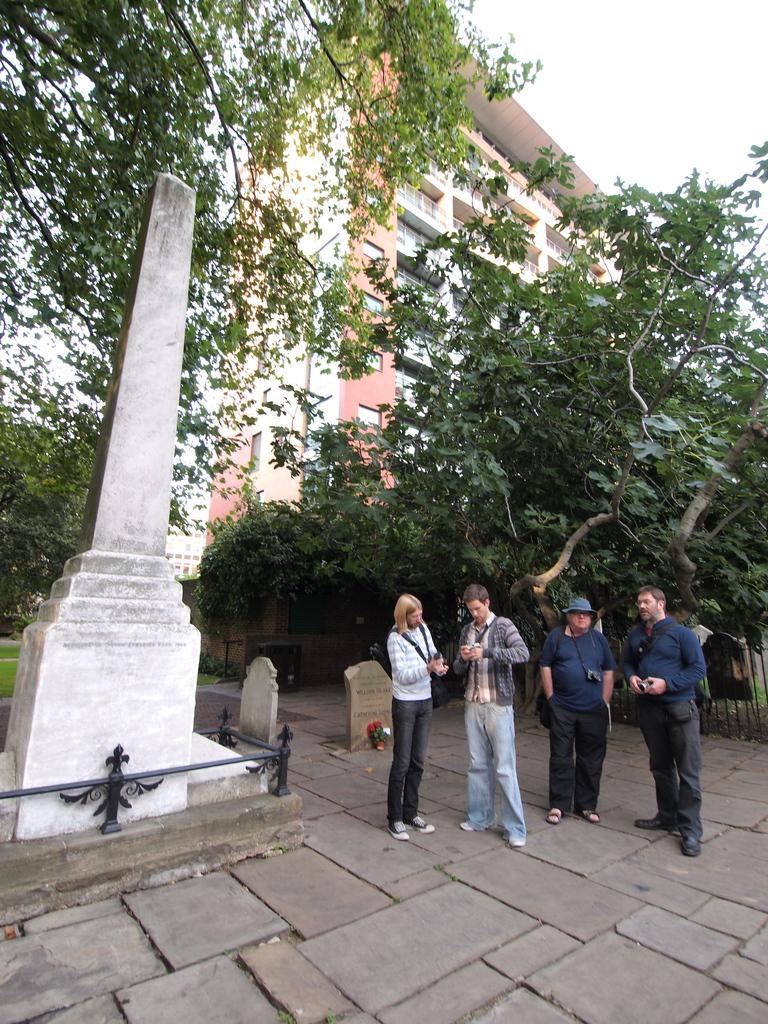Can you describe this image briefly? In the foreground I can see four persons are standing on the road in front of cemetery. In the background I can see trees, building and the sky. This image is taken during a day. 